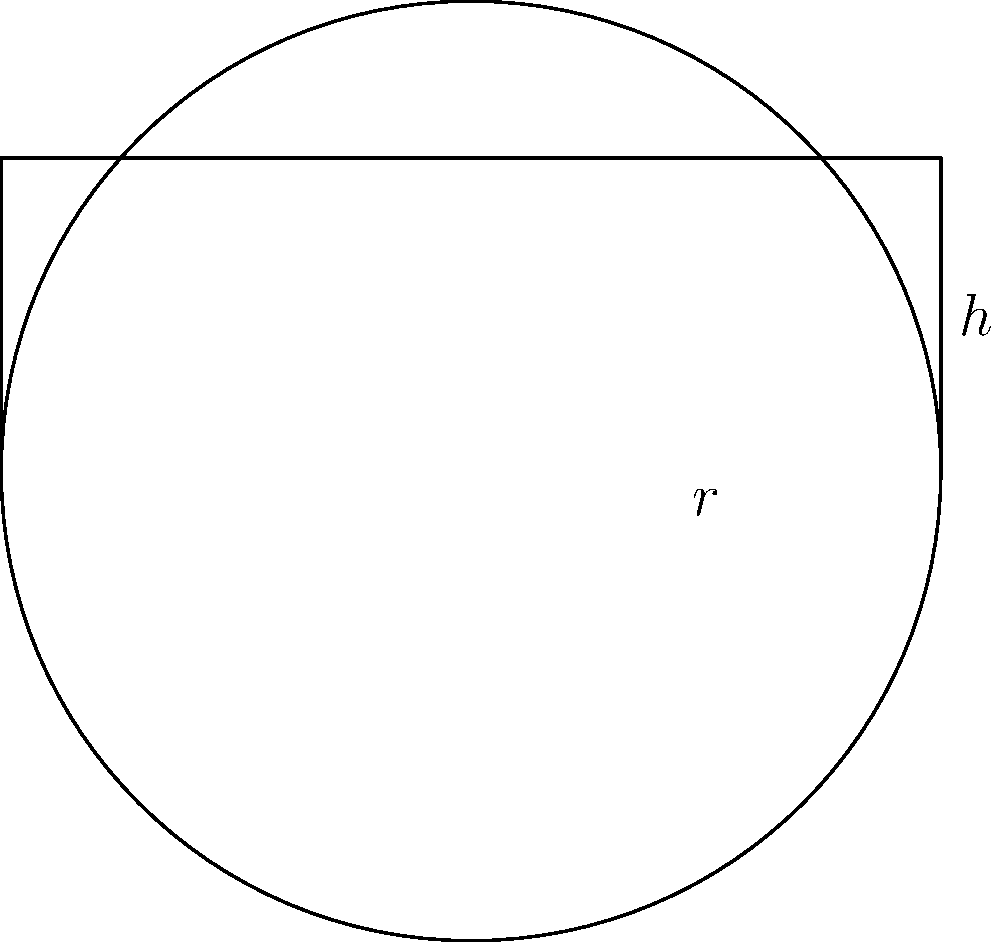A traditional Inuit drum is shaped like a cylinder with a circular base. If the radius of the drum's circular face is 15 cm and its height is 10 cm, what is the volume of the drum in cubic centimeters? Round your answer to the nearest whole number. To calculate the volume of a cylindrical drum, we need to use the formula for the volume of a cylinder:

$$V = \pi r^2 h$$

Where:
$V$ = volume
$r$ = radius of the base
$h$ = height of the cylinder

Given:
$r = 15$ cm
$h = 10$ cm

Let's substitute these values into the formula:

$$V = \pi (15 \text{ cm})^2 (10 \text{ cm})$$

Simplifying:
$$V = \pi (225 \text{ cm}^2) (10 \text{ cm})$$
$$V = 2250\pi \text{ cm}^3$$

Using $\pi \approx 3.14159$:
$$V \approx 2250 \times 3.14159 \text{ cm}^3$$
$$V \approx 7068.5775 \text{ cm}^3$$

Rounding to the nearest whole number:
$$V \approx 7069 \text{ cm}^3$$
Answer: 7069 cm³ 